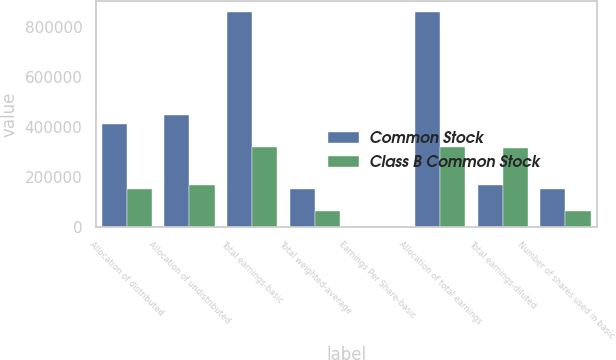Convert chart. <chart><loc_0><loc_0><loc_500><loc_500><stacked_bar_chart><ecel><fcel>Allocation of distributed<fcel>Allocation of undistributed<fcel>Total earnings-basic<fcel>Total weighted-average<fcel>Earnings Per Share-basic<fcel>Allocation of total earnings<fcel>Total earnings-diluted<fcel>Number of shares used in basic<nl><fcel>Common Stock<fcel>410732<fcel>449372<fcel>860104<fcel>149379<fcel>5.76<fcel>860104<fcel>165669<fcel>149379<nl><fcel>Class B Common Stock<fcel>151789<fcel>165669<fcel>317458<fcel>60614<fcel>5.24<fcel>317458<fcel>316655<fcel>60614<nl></chart> 